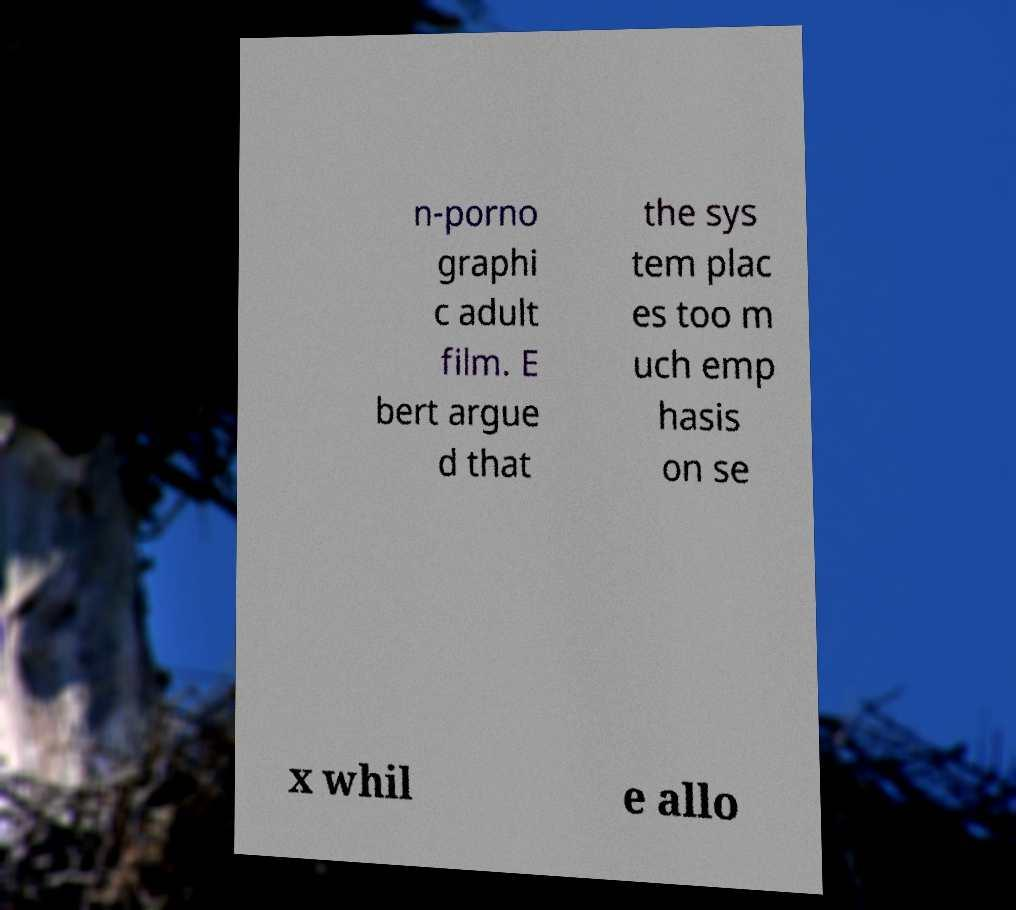For documentation purposes, I need the text within this image transcribed. Could you provide that? n-porno graphi c adult film. E bert argue d that the sys tem plac es too m uch emp hasis on se x whil e allo 